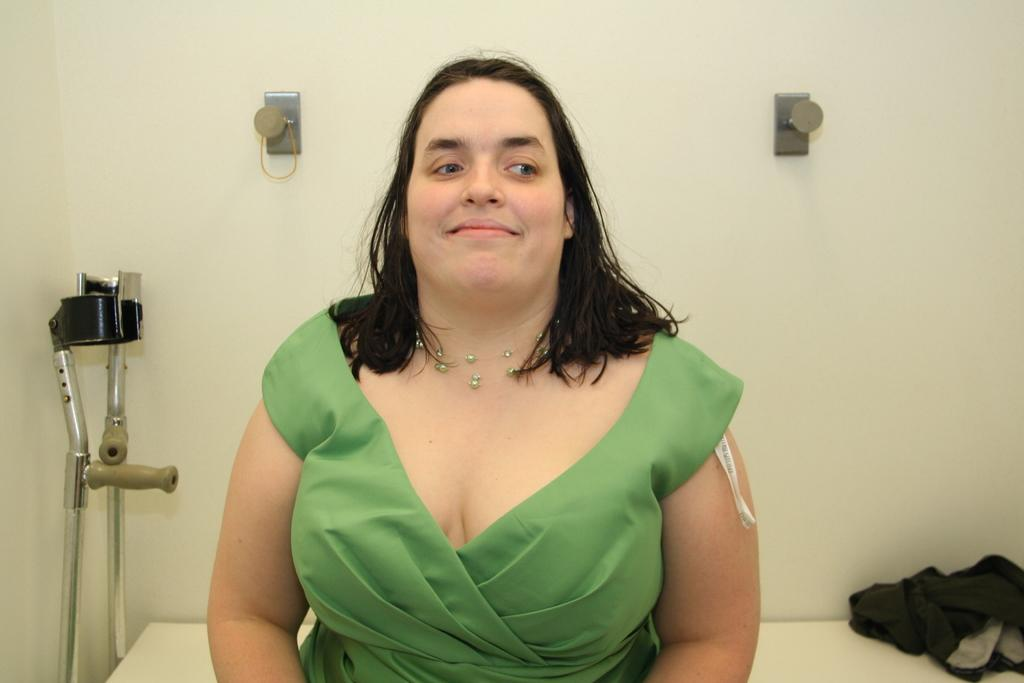Who is present in the image? There is a woman in the image. What can be seen on the table in the image? There are clothes on a table in the image. What is in the background of the image? There is a wall in the image. What object is being used for support in the image? There is a walking stick in the image. What color is the zephyr in the image? There is no zephyr present in the image; a zephyr refers to a gentle breeze, which cannot be seen. 